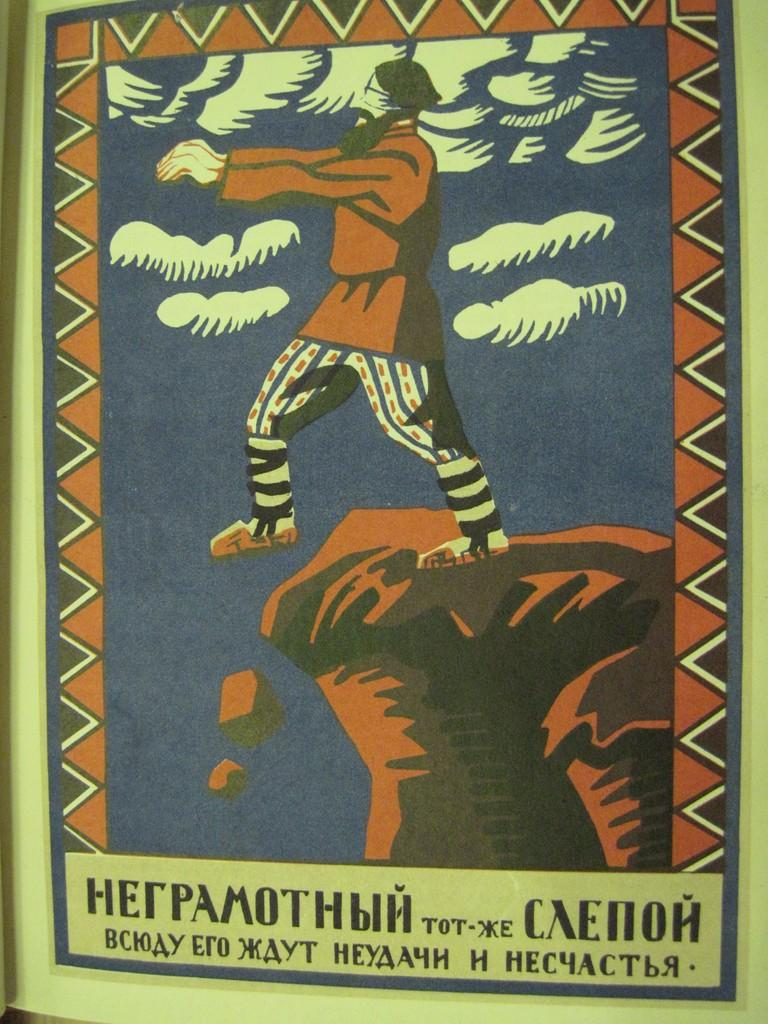What can be seen on the poster in the image? There is a poster in the image, but the specific content is not mentioned in the facts. What type of information is present in the image? There is text in the image, which may provide information or context. What type of hook is hanging from the poster in the image? There is no hook present in the image; it only mentions a poster and text. 